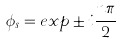Convert formula to latex. <formula><loc_0><loc_0><loc_500><loc_500>\phi _ { s } = e x p \pm i \frac { n \pi } { 2 }</formula> 